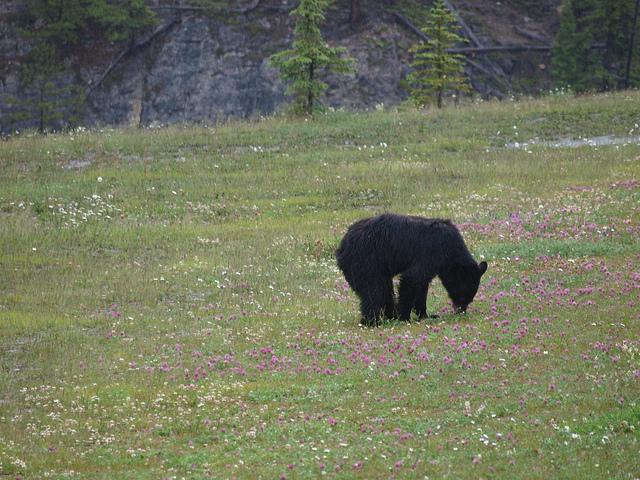What is the animal doing?
Give a very brief answer. Eating. Is this bear in captivity?
Give a very brief answer. No. What kind of bear is this?
Answer briefly. Black. Is this animal facing the camera?
Quick response, please. No. What color is the animal?
Concise answer only. Black. Can you see green in the picture?
Keep it brief. Yes. Where is the animal kept?
Quick response, please. Forest. 